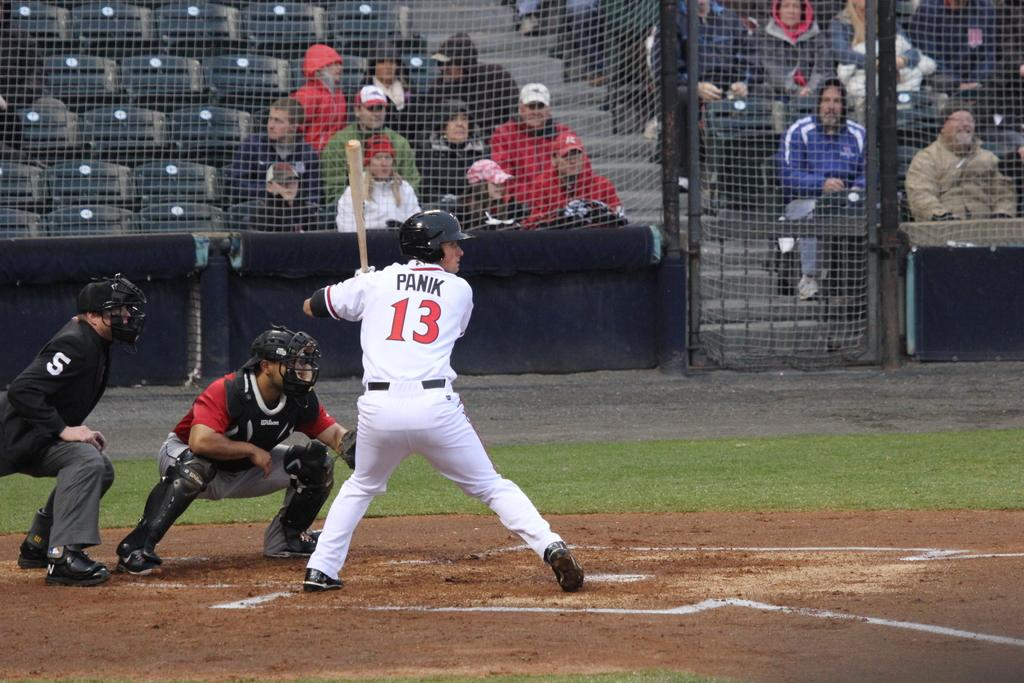<image>
Provide a brief description of the given image. a player with 13 on their jersey playing baseball 